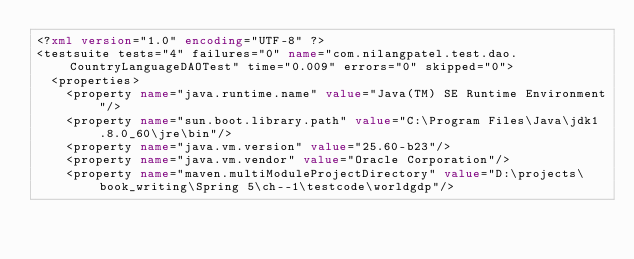<code> <loc_0><loc_0><loc_500><loc_500><_XML_><?xml version="1.0" encoding="UTF-8" ?>
<testsuite tests="4" failures="0" name="com.nilangpatel.test.dao.CountryLanguageDAOTest" time="0.009" errors="0" skipped="0">
  <properties>
    <property name="java.runtime.name" value="Java(TM) SE Runtime Environment"/>
    <property name="sun.boot.library.path" value="C:\Program Files\Java\jdk1.8.0_60\jre\bin"/>
    <property name="java.vm.version" value="25.60-b23"/>
    <property name="java.vm.vendor" value="Oracle Corporation"/>
    <property name="maven.multiModuleProjectDirectory" value="D:\projects\book_writing\Spring 5\ch--1\testcode\worldgdp"/></code> 